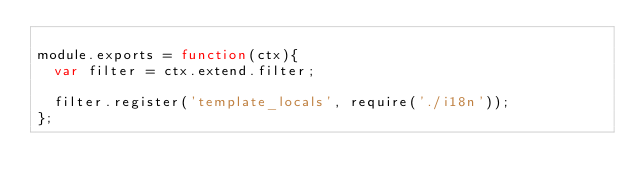<code> <loc_0><loc_0><loc_500><loc_500><_JavaScript_>
module.exports = function(ctx){
  var filter = ctx.extend.filter;

  filter.register('template_locals', require('./i18n'));
};</code> 